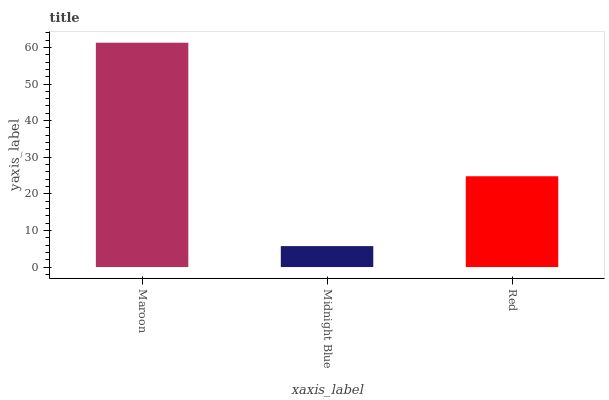Is Midnight Blue the minimum?
Answer yes or no. Yes. Is Maroon the maximum?
Answer yes or no. Yes. Is Red the minimum?
Answer yes or no. No. Is Red the maximum?
Answer yes or no. No. Is Red greater than Midnight Blue?
Answer yes or no. Yes. Is Midnight Blue less than Red?
Answer yes or no. Yes. Is Midnight Blue greater than Red?
Answer yes or no. No. Is Red less than Midnight Blue?
Answer yes or no. No. Is Red the high median?
Answer yes or no. Yes. Is Red the low median?
Answer yes or no. Yes. Is Midnight Blue the high median?
Answer yes or no. No. Is Maroon the low median?
Answer yes or no. No. 